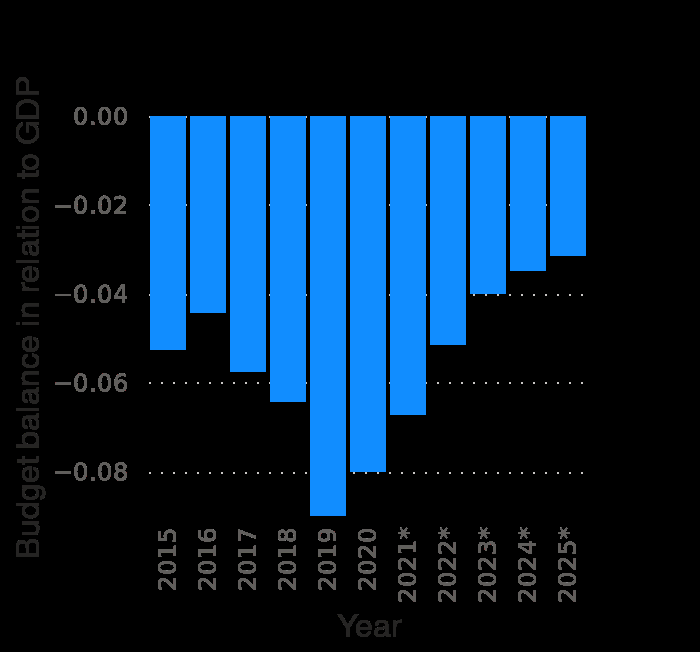<image>
How does the budget balance in relation to GDP in 2019 compare to the forecast for 2025? The budget balance in relation to GDP in 2019 was lower, going over -0.08, while the forecast for 2025 predicts it to improve to -0.03. What was the budget balance in relation to GDP in 2019?  The budget balance in relation to GDP in 2019 was the lowest going over -0.08. 